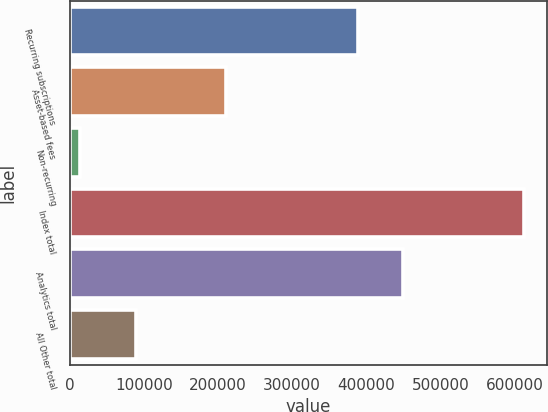Convert chart. <chart><loc_0><loc_0><loc_500><loc_500><bar_chart><fcel>Recurring subscriptions<fcel>Asset-based fees<fcel>Non-recurring<fcel>Index total<fcel>Analytics total<fcel>All Other total<nl><fcel>389348<fcel>210229<fcel>13974<fcel>613551<fcel>449306<fcel>88765<nl></chart> 